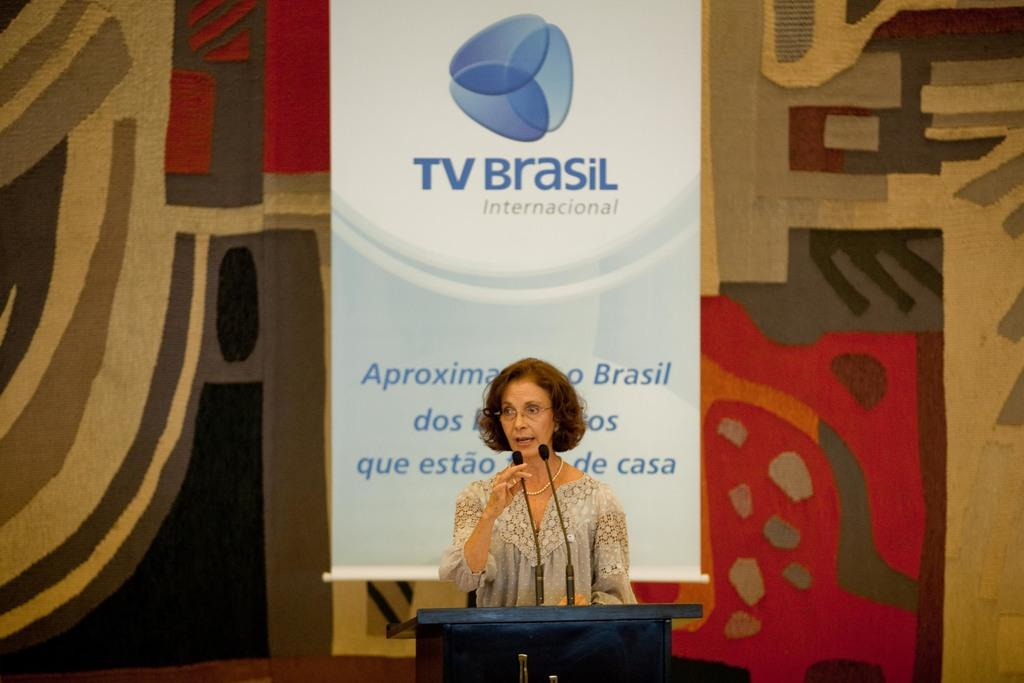<image>
Create a compact narrative representing the image presented. A woman stands at a podium with a TV Brasil banner in the background 